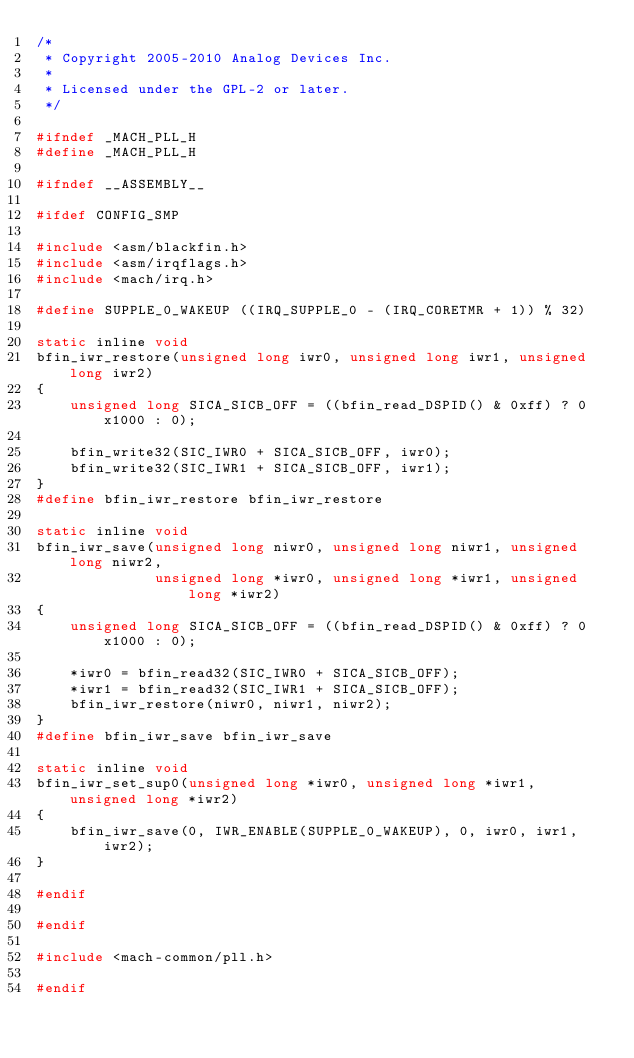Convert code to text. <code><loc_0><loc_0><loc_500><loc_500><_C_>/*
 * Copyright 2005-2010 Analog Devices Inc.
 *
 * Licensed under the GPL-2 or later.
 */

#ifndef _MACH_PLL_H
#define _MACH_PLL_H

#ifndef __ASSEMBLY__

#ifdef CONFIG_SMP

#include <asm/blackfin.h>
#include <asm/irqflags.h>
#include <mach/irq.h>

#define SUPPLE_0_WAKEUP ((IRQ_SUPPLE_0 - (IRQ_CORETMR + 1)) % 32)

static inline void
bfin_iwr_restore(unsigned long iwr0, unsigned long iwr1, unsigned long iwr2)
{
	unsigned long SICA_SICB_OFF = ((bfin_read_DSPID() & 0xff) ? 0x1000 : 0);

	bfin_write32(SIC_IWR0 + SICA_SICB_OFF, iwr0);
	bfin_write32(SIC_IWR1 + SICA_SICB_OFF, iwr1);
}
#define bfin_iwr_restore bfin_iwr_restore

static inline void
bfin_iwr_save(unsigned long niwr0, unsigned long niwr1, unsigned long niwr2,
              unsigned long *iwr0, unsigned long *iwr1, unsigned long *iwr2)
{
	unsigned long SICA_SICB_OFF = ((bfin_read_DSPID() & 0xff) ? 0x1000 : 0);

	*iwr0 = bfin_read32(SIC_IWR0 + SICA_SICB_OFF);
	*iwr1 = bfin_read32(SIC_IWR1 + SICA_SICB_OFF);
	bfin_iwr_restore(niwr0, niwr1, niwr2);
}
#define bfin_iwr_save bfin_iwr_save

static inline void
bfin_iwr_set_sup0(unsigned long *iwr0, unsigned long *iwr1, unsigned long *iwr2)
{
	bfin_iwr_save(0, IWR_ENABLE(SUPPLE_0_WAKEUP), 0, iwr0, iwr1, iwr2);
}

#endif

#endif

#include <mach-common/pll.h>

#endif
</code> 